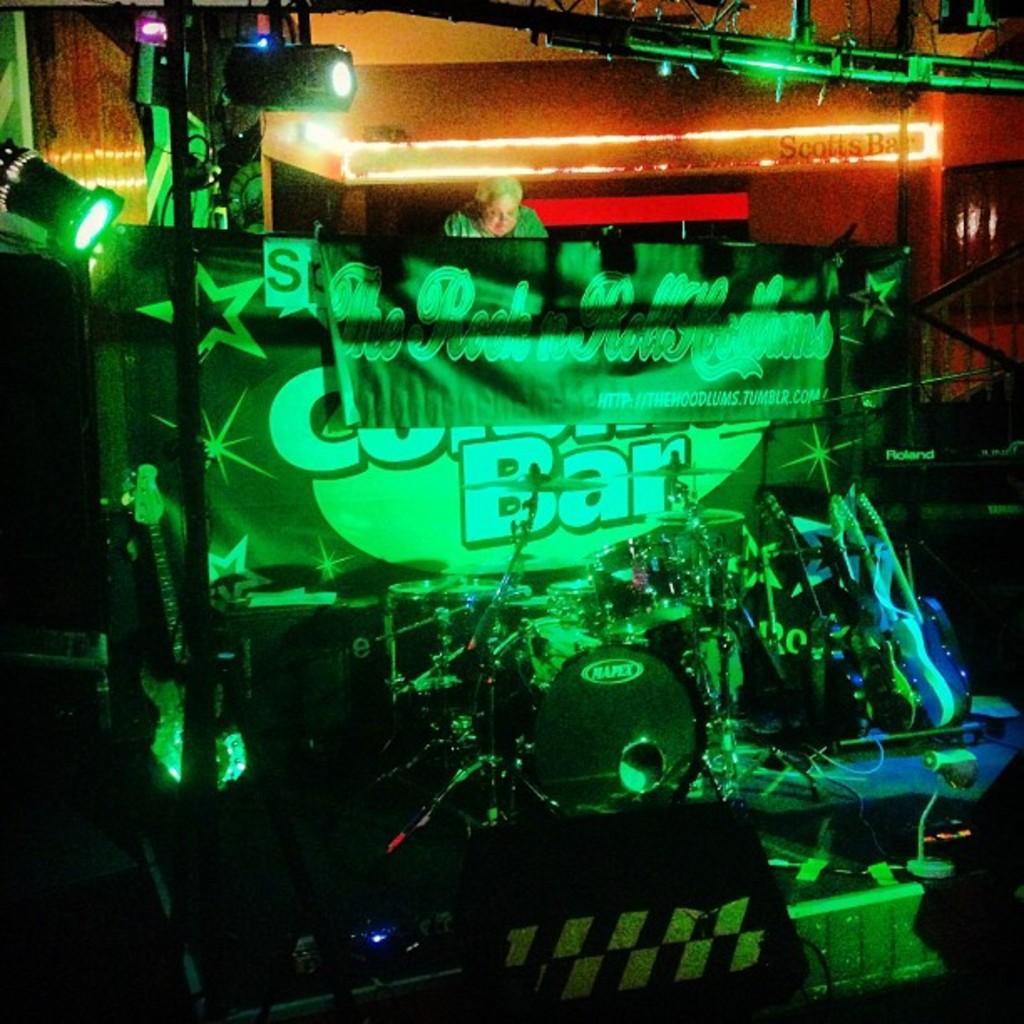Describe this image in one or two sentences. In this image I can see the drum-set and many musical instruments. In the background there is a banner. I can see the person behind the banner. I can also see many lights in the top. 